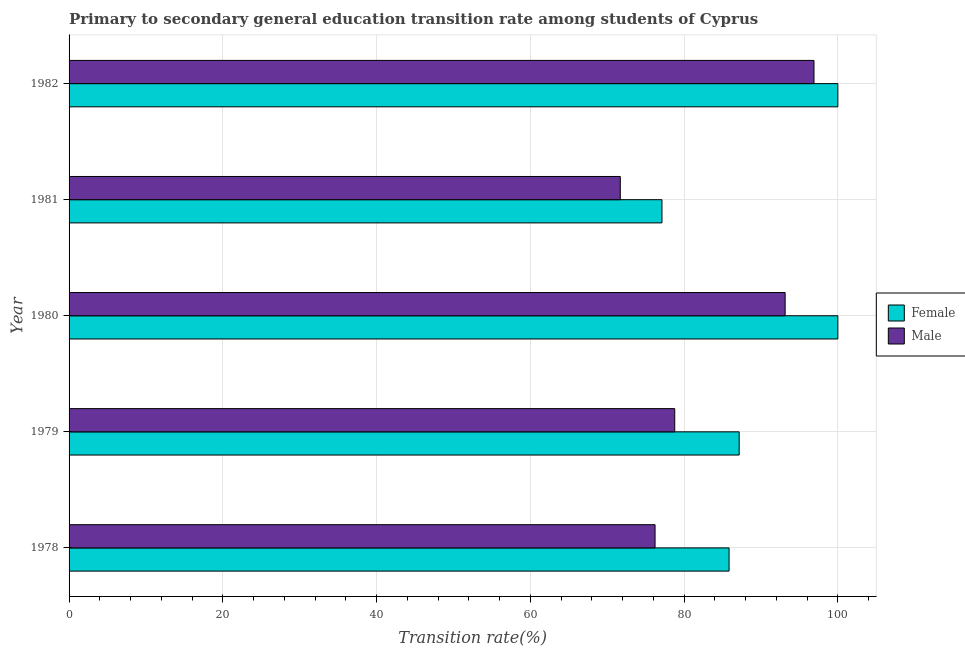How many different coloured bars are there?
Keep it short and to the point. 2. How many groups of bars are there?
Your answer should be very brief. 5. Are the number of bars on each tick of the Y-axis equal?
Your response must be concise. Yes. How many bars are there on the 2nd tick from the top?
Provide a succinct answer. 2. What is the label of the 3rd group of bars from the top?
Keep it short and to the point. 1980. What is the transition rate among female students in 1982?
Your answer should be compact. 100. Across all years, what is the maximum transition rate among male students?
Your answer should be very brief. 96.89. Across all years, what is the minimum transition rate among male students?
Provide a short and direct response. 71.7. In which year was the transition rate among female students maximum?
Ensure brevity in your answer.  1980. In which year was the transition rate among male students minimum?
Make the answer very short. 1981. What is the total transition rate among female students in the graph?
Make the answer very short. 450.13. What is the difference between the transition rate among male students in 1981 and that in 1982?
Provide a succinct answer. -25.19. What is the difference between the transition rate among male students in 1981 and the transition rate among female students in 1979?
Your response must be concise. -15.46. What is the average transition rate among female students per year?
Keep it short and to the point. 90.03. In the year 1978, what is the difference between the transition rate among male students and transition rate among female students?
Provide a succinct answer. -9.63. Is the transition rate among male students in 1978 less than that in 1982?
Keep it short and to the point. Yes. What is the difference between the highest and the second highest transition rate among male students?
Offer a very short reply. 3.75. What is the difference between the highest and the lowest transition rate among male students?
Give a very brief answer. 25.19. In how many years, is the transition rate among female students greater than the average transition rate among female students taken over all years?
Give a very brief answer. 2. Is the sum of the transition rate among female students in 1980 and 1982 greater than the maximum transition rate among male students across all years?
Your response must be concise. Yes. What does the 1st bar from the top in 1978 represents?
Your answer should be compact. Male. What does the 1st bar from the bottom in 1982 represents?
Keep it short and to the point. Female. Are all the bars in the graph horizontal?
Provide a succinct answer. Yes. How many years are there in the graph?
Provide a short and direct response. 5. Does the graph contain any zero values?
Provide a succinct answer. No. Where does the legend appear in the graph?
Provide a succinct answer. Center right. How many legend labels are there?
Make the answer very short. 2. How are the legend labels stacked?
Ensure brevity in your answer.  Vertical. What is the title of the graph?
Your response must be concise. Primary to secondary general education transition rate among students of Cyprus. What is the label or title of the X-axis?
Your answer should be compact. Transition rate(%). What is the Transition rate(%) in Female in 1978?
Keep it short and to the point. 85.85. What is the Transition rate(%) of Male in 1978?
Offer a terse response. 76.22. What is the Transition rate(%) of Female in 1979?
Ensure brevity in your answer.  87.16. What is the Transition rate(%) in Male in 1979?
Provide a succinct answer. 78.78. What is the Transition rate(%) of Female in 1980?
Offer a very short reply. 100. What is the Transition rate(%) of Male in 1980?
Keep it short and to the point. 93.14. What is the Transition rate(%) in Female in 1981?
Your answer should be compact. 77.12. What is the Transition rate(%) in Male in 1981?
Make the answer very short. 71.7. What is the Transition rate(%) of Female in 1982?
Keep it short and to the point. 100. What is the Transition rate(%) of Male in 1982?
Offer a terse response. 96.89. Across all years, what is the maximum Transition rate(%) in Female?
Your answer should be very brief. 100. Across all years, what is the maximum Transition rate(%) in Male?
Make the answer very short. 96.89. Across all years, what is the minimum Transition rate(%) of Female?
Keep it short and to the point. 77.12. Across all years, what is the minimum Transition rate(%) in Male?
Your answer should be compact. 71.7. What is the total Transition rate(%) in Female in the graph?
Your answer should be compact. 450.13. What is the total Transition rate(%) of Male in the graph?
Your answer should be very brief. 416.74. What is the difference between the Transition rate(%) in Female in 1978 and that in 1979?
Give a very brief answer. -1.31. What is the difference between the Transition rate(%) of Male in 1978 and that in 1979?
Offer a terse response. -2.56. What is the difference between the Transition rate(%) of Female in 1978 and that in 1980?
Provide a short and direct response. -14.15. What is the difference between the Transition rate(%) of Male in 1978 and that in 1980?
Make the answer very short. -16.92. What is the difference between the Transition rate(%) of Female in 1978 and that in 1981?
Give a very brief answer. 8.73. What is the difference between the Transition rate(%) in Male in 1978 and that in 1981?
Offer a terse response. 4.52. What is the difference between the Transition rate(%) in Female in 1978 and that in 1982?
Offer a terse response. -14.15. What is the difference between the Transition rate(%) in Male in 1978 and that in 1982?
Provide a short and direct response. -20.67. What is the difference between the Transition rate(%) of Female in 1979 and that in 1980?
Provide a short and direct response. -12.84. What is the difference between the Transition rate(%) in Male in 1979 and that in 1980?
Keep it short and to the point. -14.36. What is the difference between the Transition rate(%) of Female in 1979 and that in 1981?
Your answer should be compact. 10.04. What is the difference between the Transition rate(%) of Male in 1979 and that in 1981?
Make the answer very short. 7.08. What is the difference between the Transition rate(%) in Female in 1979 and that in 1982?
Your answer should be compact. -12.84. What is the difference between the Transition rate(%) in Male in 1979 and that in 1982?
Provide a short and direct response. -18.11. What is the difference between the Transition rate(%) in Female in 1980 and that in 1981?
Your answer should be very brief. 22.88. What is the difference between the Transition rate(%) of Male in 1980 and that in 1981?
Make the answer very short. 21.44. What is the difference between the Transition rate(%) in Female in 1980 and that in 1982?
Ensure brevity in your answer.  0. What is the difference between the Transition rate(%) of Male in 1980 and that in 1982?
Offer a very short reply. -3.75. What is the difference between the Transition rate(%) of Female in 1981 and that in 1982?
Offer a terse response. -22.88. What is the difference between the Transition rate(%) in Male in 1981 and that in 1982?
Provide a short and direct response. -25.19. What is the difference between the Transition rate(%) of Female in 1978 and the Transition rate(%) of Male in 1979?
Keep it short and to the point. 7.07. What is the difference between the Transition rate(%) in Female in 1978 and the Transition rate(%) in Male in 1980?
Your answer should be very brief. -7.29. What is the difference between the Transition rate(%) of Female in 1978 and the Transition rate(%) of Male in 1981?
Your answer should be compact. 14.15. What is the difference between the Transition rate(%) of Female in 1978 and the Transition rate(%) of Male in 1982?
Offer a terse response. -11.04. What is the difference between the Transition rate(%) in Female in 1979 and the Transition rate(%) in Male in 1980?
Make the answer very short. -5.98. What is the difference between the Transition rate(%) in Female in 1979 and the Transition rate(%) in Male in 1981?
Provide a succinct answer. 15.46. What is the difference between the Transition rate(%) in Female in 1979 and the Transition rate(%) in Male in 1982?
Offer a terse response. -9.73. What is the difference between the Transition rate(%) in Female in 1980 and the Transition rate(%) in Male in 1981?
Provide a succinct answer. 28.3. What is the difference between the Transition rate(%) of Female in 1980 and the Transition rate(%) of Male in 1982?
Offer a very short reply. 3.11. What is the difference between the Transition rate(%) of Female in 1981 and the Transition rate(%) of Male in 1982?
Your answer should be very brief. -19.77. What is the average Transition rate(%) in Female per year?
Your response must be concise. 90.03. What is the average Transition rate(%) in Male per year?
Give a very brief answer. 83.35. In the year 1978, what is the difference between the Transition rate(%) of Female and Transition rate(%) of Male?
Offer a very short reply. 9.63. In the year 1979, what is the difference between the Transition rate(%) in Female and Transition rate(%) in Male?
Your answer should be very brief. 8.38. In the year 1980, what is the difference between the Transition rate(%) of Female and Transition rate(%) of Male?
Give a very brief answer. 6.86. In the year 1981, what is the difference between the Transition rate(%) of Female and Transition rate(%) of Male?
Ensure brevity in your answer.  5.42. In the year 1982, what is the difference between the Transition rate(%) of Female and Transition rate(%) of Male?
Offer a terse response. 3.11. What is the ratio of the Transition rate(%) in Female in 1978 to that in 1979?
Your answer should be compact. 0.98. What is the ratio of the Transition rate(%) of Male in 1978 to that in 1979?
Offer a very short reply. 0.97. What is the ratio of the Transition rate(%) in Female in 1978 to that in 1980?
Give a very brief answer. 0.86. What is the ratio of the Transition rate(%) in Male in 1978 to that in 1980?
Offer a terse response. 0.82. What is the ratio of the Transition rate(%) in Female in 1978 to that in 1981?
Ensure brevity in your answer.  1.11. What is the ratio of the Transition rate(%) of Male in 1978 to that in 1981?
Your answer should be very brief. 1.06. What is the ratio of the Transition rate(%) in Female in 1978 to that in 1982?
Offer a terse response. 0.86. What is the ratio of the Transition rate(%) of Male in 1978 to that in 1982?
Ensure brevity in your answer.  0.79. What is the ratio of the Transition rate(%) of Female in 1979 to that in 1980?
Ensure brevity in your answer.  0.87. What is the ratio of the Transition rate(%) in Male in 1979 to that in 1980?
Provide a succinct answer. 0.85. What is the ratio of the Transition rate(%) of Female in 1979 to that in 1981?
Your answer should be very brief. 1.13. What is the ratio of the Transition rate(%) in Male in 1979 to that in 1981?
Offer a very short reply. 1.1. What is the ratio of the Transition rate(%) in Female in 1979 to that in 1982?
Your answer should be compact. 0.87. What is the ratio of the Transition rate(%) of Male in 1979 to that in 1982?
Provide a succinct answer. 0.81. What is the ratio of the Transition rate(%) in Female in 1980 to that in 1981?
Provide a short and direct response. 1.3. What is the ratio of the Transition rate(%) in Male in 1980 to that in 1981?
Keep it short and to the point. 1.3. What is the ratio of the Transition rate(%) in Male in 1980 to that in 1982?
Keep it short and to the point. 0.96. What is the ratio of the Transition rate(%) of Female in 1981 to that in 1982?
Your answer should be compact. 0.77. What is the ratio of the Transition rate(%) in Male in 1981 to that in 1982?
Keep it short and to the point. 0.74. What is the difference between the highest and the second highest Transition rate(%) in Female?
Ensure brevity in your answer.  0. What is the difference between the highest and the second highest Transition rate(%) in Male?
Your answer should be very brief. 3.75. What is the difference between the highest and the lowest Transition rate(%) in Female?
Keep it short and to the point. 22.88. What is the difference between the highest and the lowest Transition rate(%) in Male?
Provide a short and direct response. 25.19. 